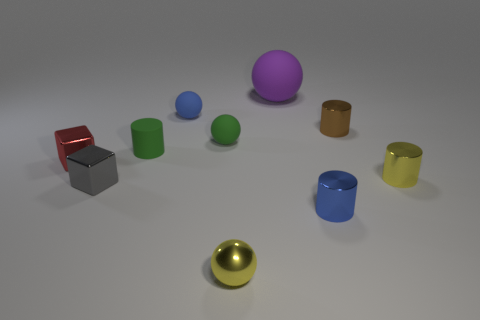Subtract all cubes. How many objects are left? 8 Add 5 gray metal cubes. How many gray metal cubes are left? 6 Add 7 large objects. How many large objects exist? 8 Subtract 0 yellow cubes. How many objects are left? 10 Subtract all yellow matte cylinders. Subtract all metallic spheres. How many objects are left? 9 